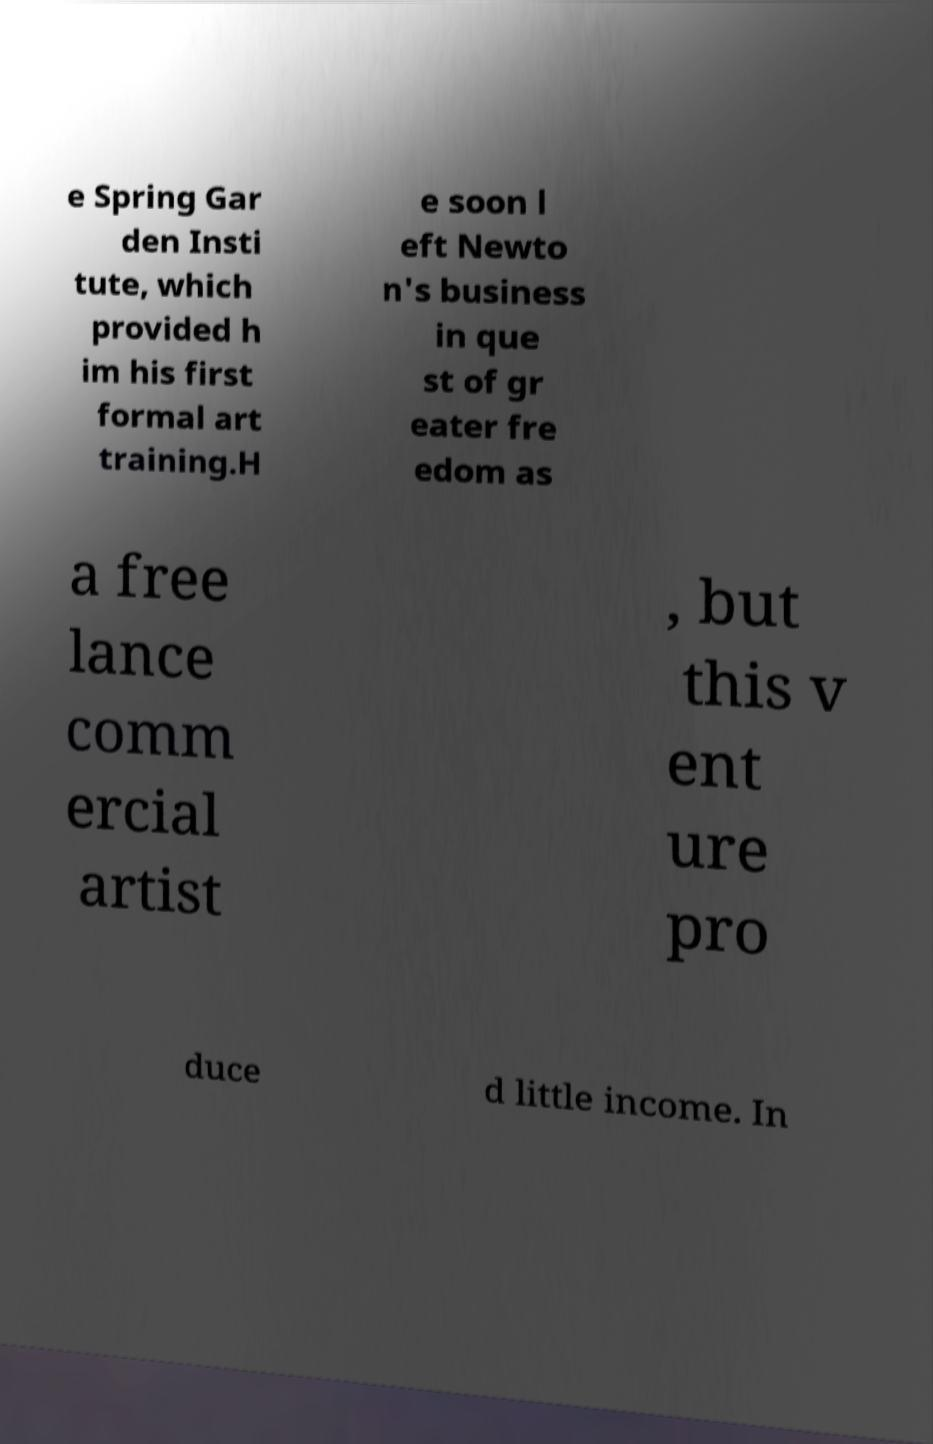For documentation purposes, I need the text within this image transcribed. Could you provide that? e Spring Gar den Insti tute, which provided h im his first formal art training.H e soon l eft Newto n's business in que st of gr eater fre edom as a free lance comm ercial artist , but this v ent ure pro duce d little income. In 